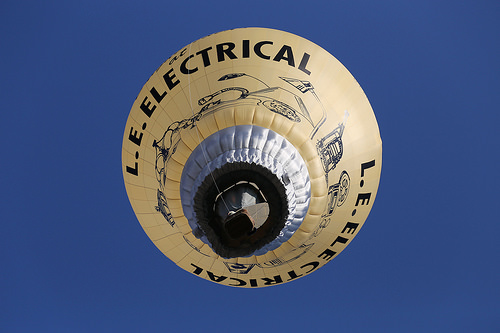<image>
Is there a design in the parachute? Yes. The design is contained within or inside the parachute, showing a containment relationship. 